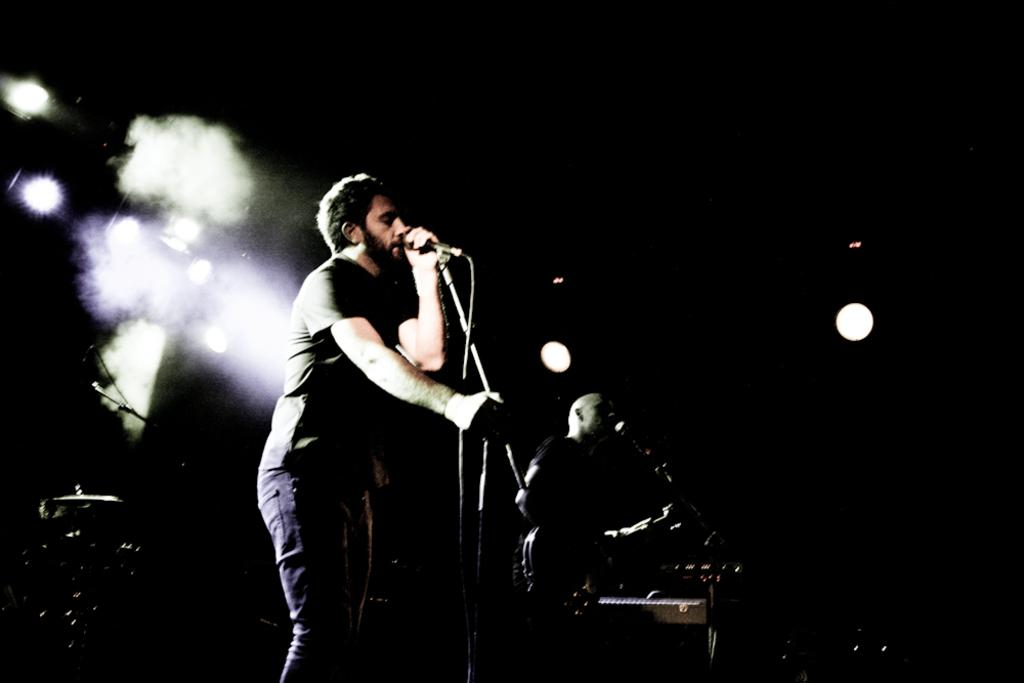What are the persons on stage doing in the image? The persons on stage are playing musical instruments. What can be seen in the background of the image? There are lights in the background of the image, and the view is dark. What song is the band playing in the image? There is no song being played in the image, as it only shows the persons on stage playing musical instruments. What type of jam can be seen on the table in the image? There is no table or jam present in the image; it features persons on stage playing musical instruments. 